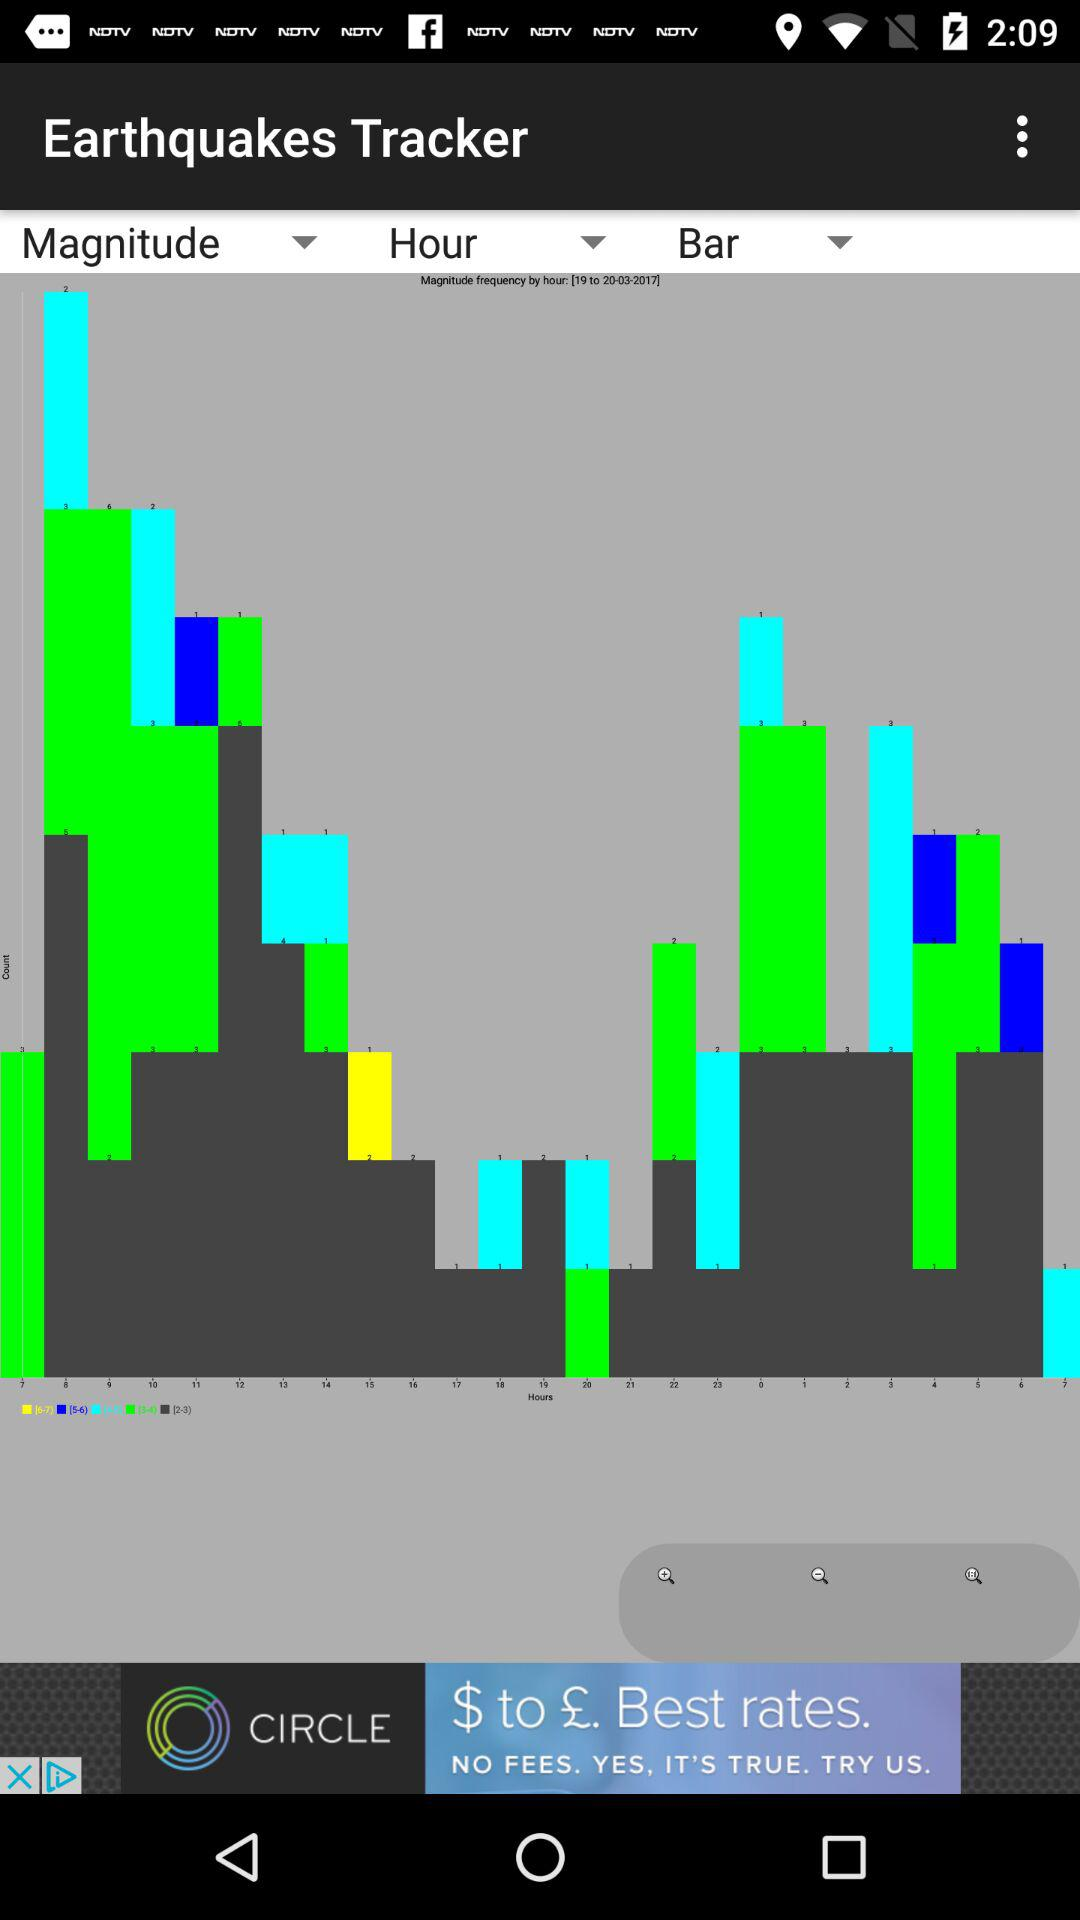What is the name of the application? The name of the application is "Earthquakes Tracker". 